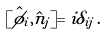<formula> <loc_0><loc_0><loc_500><loc_500>[ \hat { \phi } _ { i } , \hat { n } _ { j } ] = i \delta _ { i j } \, .</formula> 